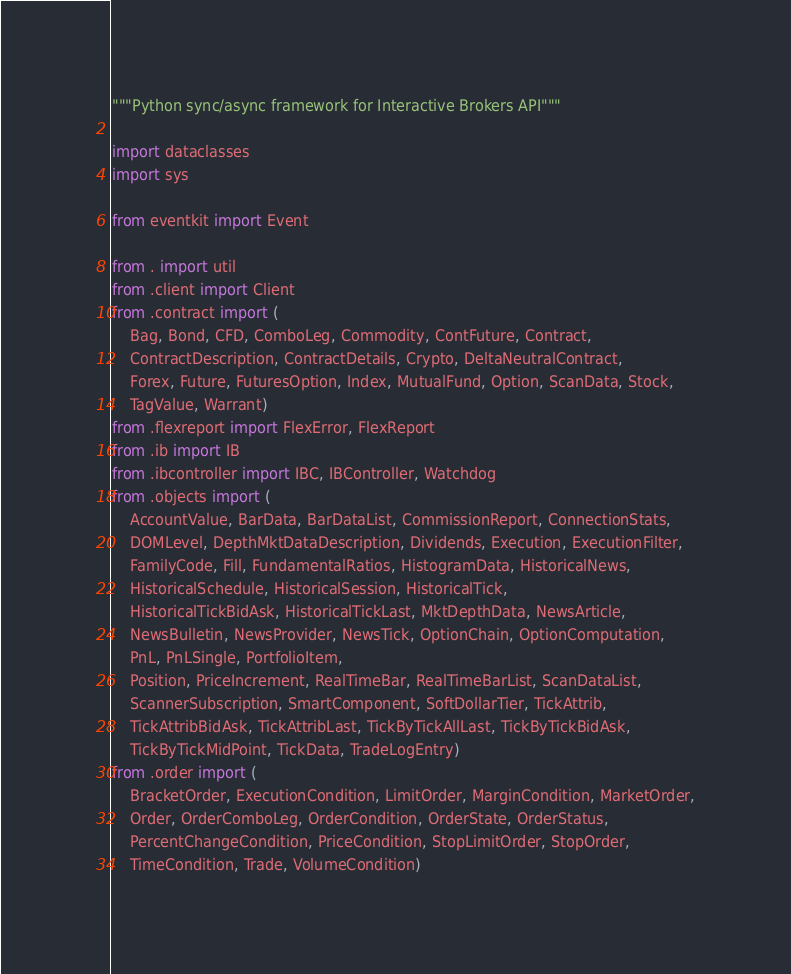Convert code to text. <code><loc_0><loc_0><loc_500><loc_500><_Python_>"""Python sync/async framework for Interactive Brokers API"""

import dataclasses
import sys

from eventkit import Event

from . import util
from .client import Client
from .contract import (
    Bag, Bond, CFD, ComboLeg, Commodity, ContFuture, Contract,
    ContractDescription, ContractDetails, Crypto, DeltaNeutralContract,
    Forex, Future, FuturesOption, Index, MutualFund, Option, ScanData, Stock,
    TagValue, Warrant)
from .flexreport import FlexError, FlexReport
from .ib import IB
from .ibcontroller import IBC, IBController, Watchdog
from .objects import (
    AccountValue, BarData, BarDataList, CommissionReport, ConnectionStats,
    DOMLevel, DepthMktDataDescription, Dividends, Execution, ExecutionFilter,
    FamilyCode, Fill, FundamentalRatios, HistogramData, HistoricalNews,
    HistoricalSchedule, HistoricalSession, HistoricalTick,
    HistoricalTickBidAsk, HistoricalTickLast, MktDepthData, NewsArticle,
    NewsBulletin, NewsProvider, NewsTick, OptionChain, OptionComputation,
    PnL, PnLSingle, PortfolioItem,
    Position, PriceIncrement, RealTimeBar, RealTimeBarList, ScanDataList,
    ScannerSubscription, SmartComponent, SoftDollarTier, TickAttrib,
    TickAttribBidAsk, TickAttribLast, TickByTickAllLast, TickByTickBidAsk,
    TickByTickMidPoint, TickData, TradeLogEntry)
from .order import (
    BracketOrder, ExecutionCondition, LimitOrder, MarginCondition, MarketOrder,
    Order, OrderComboLeg, OrderCondition, OrderState, OrderStatus,
    PercentChangeCondition, PriceCondition, StopLimitOrder, StopOrder,
    TimeCondition, Trade, VolumeCondition)</code> 